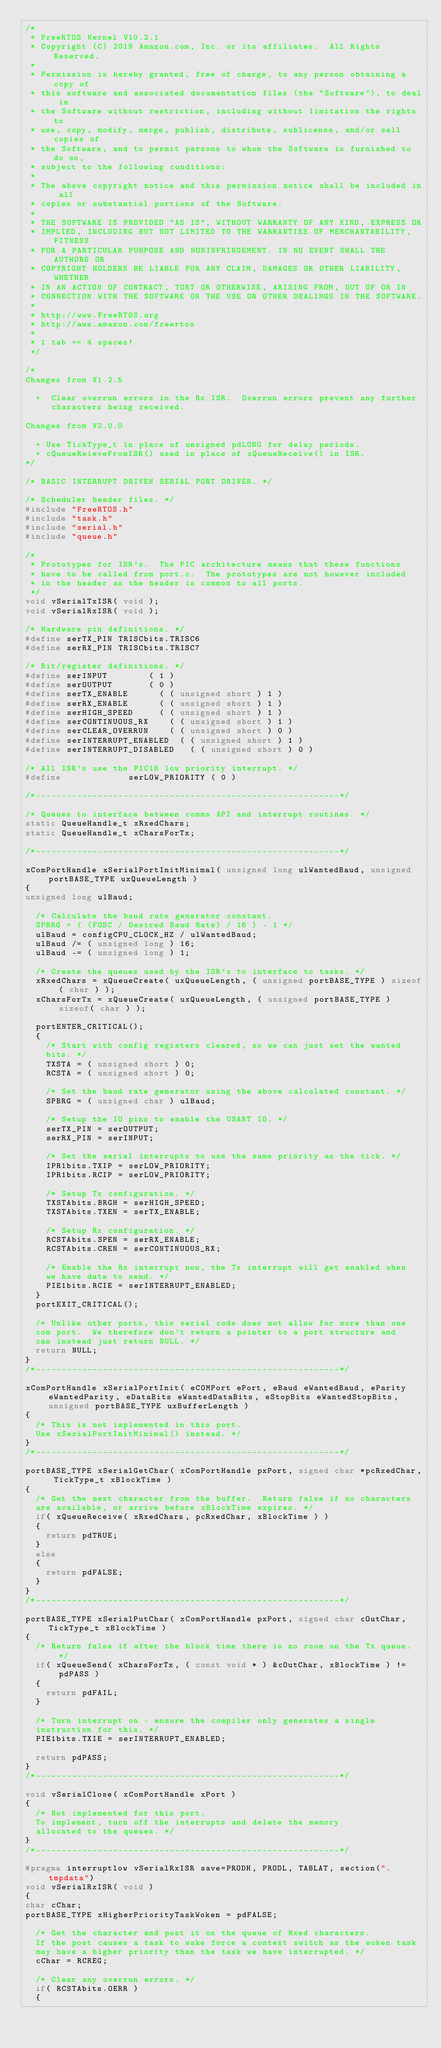<code> <loc_0><loc_0><loc_500><loc_500><_C_>/*
 * FreeRTOS Kernel V10.2.1
 * Copyright (C) 2019 Amazon.com, Inc. or its affiliates.  All Rights Reserved.
 *
 * Permission is hereby granted, free of charge, to any person obtaining a copy of
 * this software and associated documentation files (the "Software"), to deal in
 * the Software without restriction, including without limitation the rights to
 * use, copy, modify, merge, publish, distribute, sublicense, and/or sell copies of
 * the Software, and to permit persons to whom the Software is furnished to do so,
 * subject to the following conditions:
 *
 * The above copyright notice and this permission notice shall be included in all
 * copies or substantial portions of the Software.
 *
 * THE SOFTWARE IS PROVIDED "AS IS", WITHOUT WARRANTY OF ANY KIND, EXPRESS OR
 * IMPLIED, INCLUDING BUT NOT LIMITED TO THE WARRANTIES OF MERCHANTABILITY, FITNESS
 * FOR A PARTICULAR PURPOSE AND NONINFRINGEMENT. IN NO EVENT SHALL THE AUTHORS OR
 * COPYRIGHT HOLDERS BE LIABLE FOR ANY CLAIM, DAMAGES OR OTHER LIABILITY, WHETHER
 * IN AN ACTION OF CONTRACT, TORT OR OTHERWISE, ARISING FROM, OUT OF OR IN
 * CONNECTION WITH THE SOFTWARE OR THE USE OR OTHER DEALINGS IN THE SOFTWARE.
 *
 * http://www.FreeRTOS.org
 * http://aws.amazon.com/freertos
 *
 * 1 tab == 4 spaces!
 */

/*
Changes from V1.2.5

	+  Clear overrun errors in the Rx ISR.  Overrun errors prevent any further
	   characters being received.

Changes from V2.0.0

	+ Use TickType_t in place of unsigned pdLONG for delay periods.
	+ cQueueReieveFromISR() used in place of xQueueReceive() in ISR.
*/

/* BASIC INTERRUPT DRIVEN SERIAL PORT DRIVER. */

/* Scheduler header files. */
#include "FreeRTOS.h"
#include "task.h"
#include "serial.h"
#include "queue.h"

/*
 * Prototypes for ISR's.  The PIC architecture means that these functions
 * have to be called from port.c.  The prototypes are not however included
 * in the header as the header is common to all ports.
 */
void vSerialTxISR( void );
void vSerialRxISR( void );

/* Hardware pin definitions. */
#define serTX_PIN	TRISCbits.TRISC6
#define serRX_PIN	TRISCbits.TRISC7

/* Bit/register definitions. */
#define serINPUT				( 1 )
#define serOUTPUT				( 0 )
#define serTX_ENABLE			( ( unsigned short ) 1 )
#define serRX_ENABLE			( ( unsigned short ) 1 )
#define serHIGH_SPEED			( ( unsigned short ) 1 )
#define serCONTINUOUS_RX		( ( unsigned short ) 1 )
#define serCLEAR_OVERRUN		( ( unsigned short ) 0 )
#define serINTERRUPT_ENABLED 	( ( unsigned short ) 1 )
#define serINTERRUPT_DISABLED 	( ( unsigned short ) 0 )

/* All ISR's use the PIC18 low priority interrupt. */
#define							serLOW_PRIORITY ( 0 )

/*-----------------------------------------------------------*/

/* Queues to interface between comms API and interrupt routines. */
static QueueHandle_t xRxedChars; 
static QueueHandle_t xCharsForTx;

/*-----------------------------------------------------------*/

xComPortHandle xSerialPortInitMinimal( unsigned long ulWantedBaud, unsigned portBASE_TYPE uxQueueLength )
{
unsigned long ulBaud;

	/* Calculate the baud rate generator constant.
	SPBRG = ( (FOSC / Desired Baud Rate) / 16 ) - 1 */
	ulBaud = configCPU_CLOCK_HZ / ulWantedBaud;
	ulBaud /= ( unsigned long ) 16;
	ulBaud -= ( unsigned long ) 1;

	/* Create the queues used by the ISR's to interface to tasks. */
	xRxedChars = xQueueCreate( uxQueueLength, ( unsigned portBASE_TYPE ) sizeof( char ) );
	xCharsForTx = xQueueCreate( uxQueueLength, ( unsigned portBASE_TYPE ) sizeof( char ) );

	portENTER_CRITICAL();
	{
		/* Start with config registers cleared, so we can just set the wanted
		bits. */
		TXSTA = ( unsigned short ) 0;
		RCSTA = ( unsigned short ) 0;

		/* Set the baud rate generator using the above calculated constant. */
		SPBRG = ( unsigned char ) ulBaud;

		/* Setup the IO pins to enable the USART IO. */
		serTX_PIN = serOUTPUT;
		serRX_PIN = serINPUT;

		/* Set the serial interrupts to use the same priority as the tick. */
		IPR1bits.TXIP = serLOW_PRIORITY;
		IPR1bits.RCIP = serLOW_PRIORITY;

		/* Setup Tx configuration. */
		TXSTAbits.BRGH = serHIGH_SPEED;
		TXSTAbits.TXEN = serTX_ENABLE;

		/* Setup Rx configuration. */
		RCSTAbits.SPEN = serRX_ENABLE;
		RCSTAbits.CREN = serCONTINUOUS_RX;

		/* Enable the Rx interrupt now, the Tx interrupt will get enabled when
		we have data to send. */
		PIE1bits.RCIE = serINTERRUPT_ENABLED;
	}
	portEXIT_CRITICAL();

	/* Unlike other ports, this serial code does not allow for more than one
	com port.  We therefore don't return a pointer to a port structure and 
	can	instead just return NULL. */
	return NULL;
}
/*-----------------------------------------------------------*/

xComPortHandle xSerialPortInit( eCOMPort ePort, eBaud eWantedBaud, eParity eWantedParity, eDataBits eWantedDataBits, eStopBits eWantedStopBits, unsigned portBASE_TYPE uxBufferLength )
{
	/* This is not implemented in this port.
	Use xSerialPortInitMinimal() instead. */
}
/*-----------------------------------------------------------*/

portBASE_TYPE xSerialGetChar( xComPortHandle pxPort, signed char *pcRxedChar, TickType_t xBlockTime )
{
	/* Get the next character from the buffer.  Return false if no characters
	are available, or arrive before xBlockTime expires. */
	if( xQueueReceive( xRxedChars, pcRxedChar, xBlockTime ) )
	{
		return pdTRUE;
	}
	else
	{
		return pdFALSE;
	}
}
/*-----------------------------------------------------------*/

portBASE_TYPE xSerialPutChar( xComPortHandle pxPort, signed char cOutChar, TickType_t xBlockTime )
{
	/* Return false if after the block time there is no room on the Tx queue. */
	if( xQueueSend( xCharsForTx, ( const void * ) &cOutChar, xBlockTime ) != pdPASS )
	{
		return pdFAIL;
	}

	/* Turn interrupt on - ensure the compiler only generates a single 
	instruction for this. */
	PIE1bits.TXIE = serINTERRUPT_ENABLED;

	return pdPASS;
}
/*-----------------------------------------------------------*/

void vSerialClose( xComPortHandle xPort )
{
	/* Not implemented for this port.
	To implement, turn off the interrupts and delete the memory
	allocated to the queues. */
}
/*-----------------------------------------------------------*/

#pragma interruptlow vSerialRxISR save=PRODH, PRODL, TABLAT, section(".tmpdata")
void vSerialRxISR( void )
{
char cChar;
portBASE_TYPE xHigherPriorityTaskWoken = pdFALSE;

	/* Get the character and post it on the queue of Rxed characters.
	If the post causes a task to wake force a context switch as the woken task
	may have a higher priority than the task we have interrupted. */
	cChar = RCREG;

	/* Clear any overrun errors. */
	if( RCSTAbits.OERR )
	{</code> 